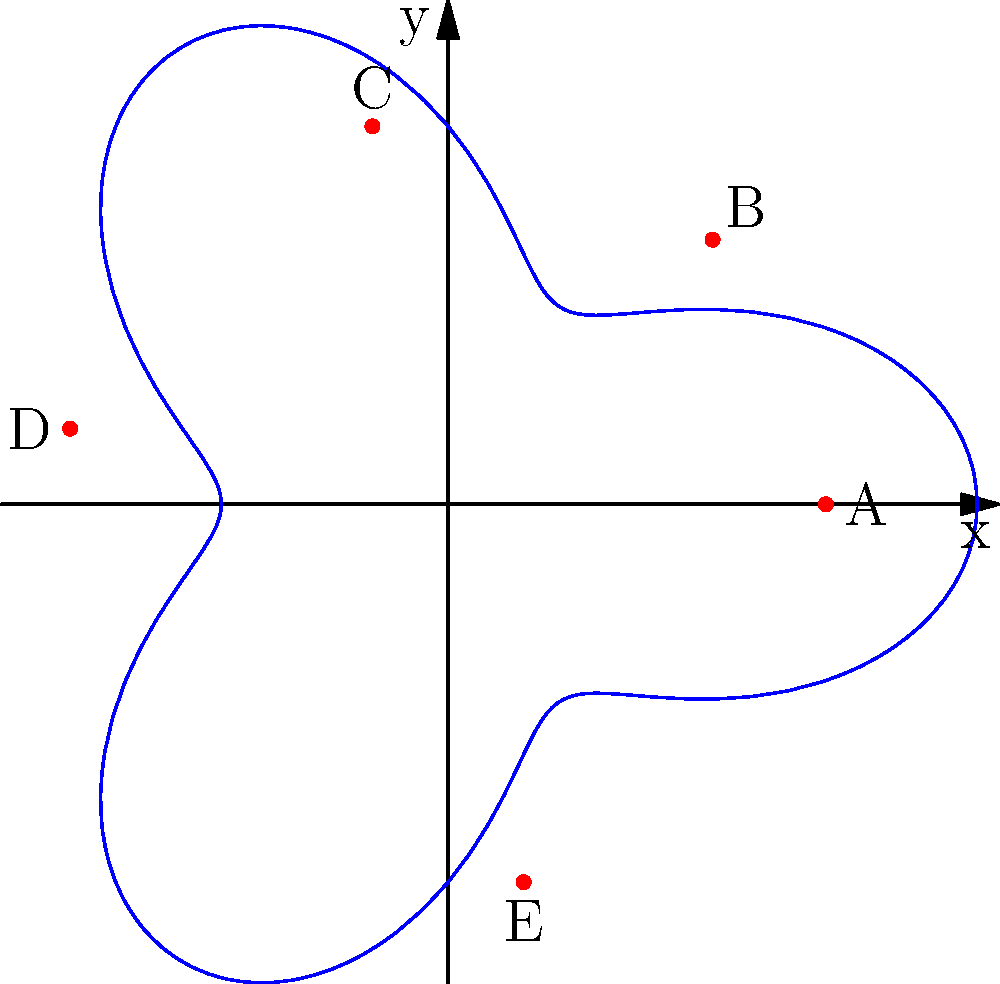You are optimizing shipping routes between five major ports (A, B, C, D, and E) along a coastline represented by the polar equation $r = 5 + 2\cos(3\theta)$. If a ship starts at port A and visits each port exactly once before returning to A, what is the optimal order of visits to minimize the total distance traveled? Assume the ship travels in straight lines between ports. To solve this problem, we need to follow these steps:

1) First, we need to determine the coordinates of each port:
   A: $(5, 0)$
   B: $(3.5, 3.5)$
   C: $(-1, 5)$
   D: $(-5, 1)$
   E: $(1, -5)$

2) Calculate the distances between each pair of ports using the distance formula:
   $d = \sqrt{(x_2-x_1)^2 + (y_2-y_1)^2}$

3) Create a distance matrix:
   
   |   | A   | B   | C   | D   | E   |
   |---|-----|-----|-----|-----|-----|
   | A | 0   | 5   | 10  | 10  | 10  |
   | B | 5   | 0   | 5   | 10  | 10  |
   | C | 10  | 5   | 0   | 5   | 10  |
   | D | 10  | 10  | 5   | 0   | 10  |
   | E | 10  | 10  | 10  | 10  | 0   |

4) Use the nearest neighbor algorithm to find an approximate optimal route:
   Start at A -> Nearest is B -> Nearest is C -> Nearest is D -> Only E left -> Return to A

5) Calculate the total distance:
   A to B: 5
   B to C: 5
   C to D: 5
   D to E: 10
   E to A: 10
   Total: 35 units

6) Check if any other permutation yields a shorter total distance. In this case, the symmetry of the problem suggests this is likely the optimal solution.

Therefore, the optimal order of visits is A -> B -> C -> D -> E -> A.
Answer: A -> B -> C -> D -> E -> A 